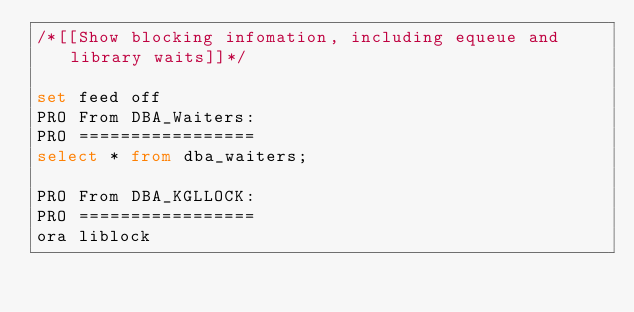<code> <loc_0><loc_0><loc_500><loc_500><_SQL_>/*[[Show blocking infomation, including equeue and library waits]]*/

set feed off
PRO From DBA_Waiters:
PRO =================
select * from dba_waiters;

PRO From DBA_KGLLOCK:
PRO =================
ora liblock</code> 